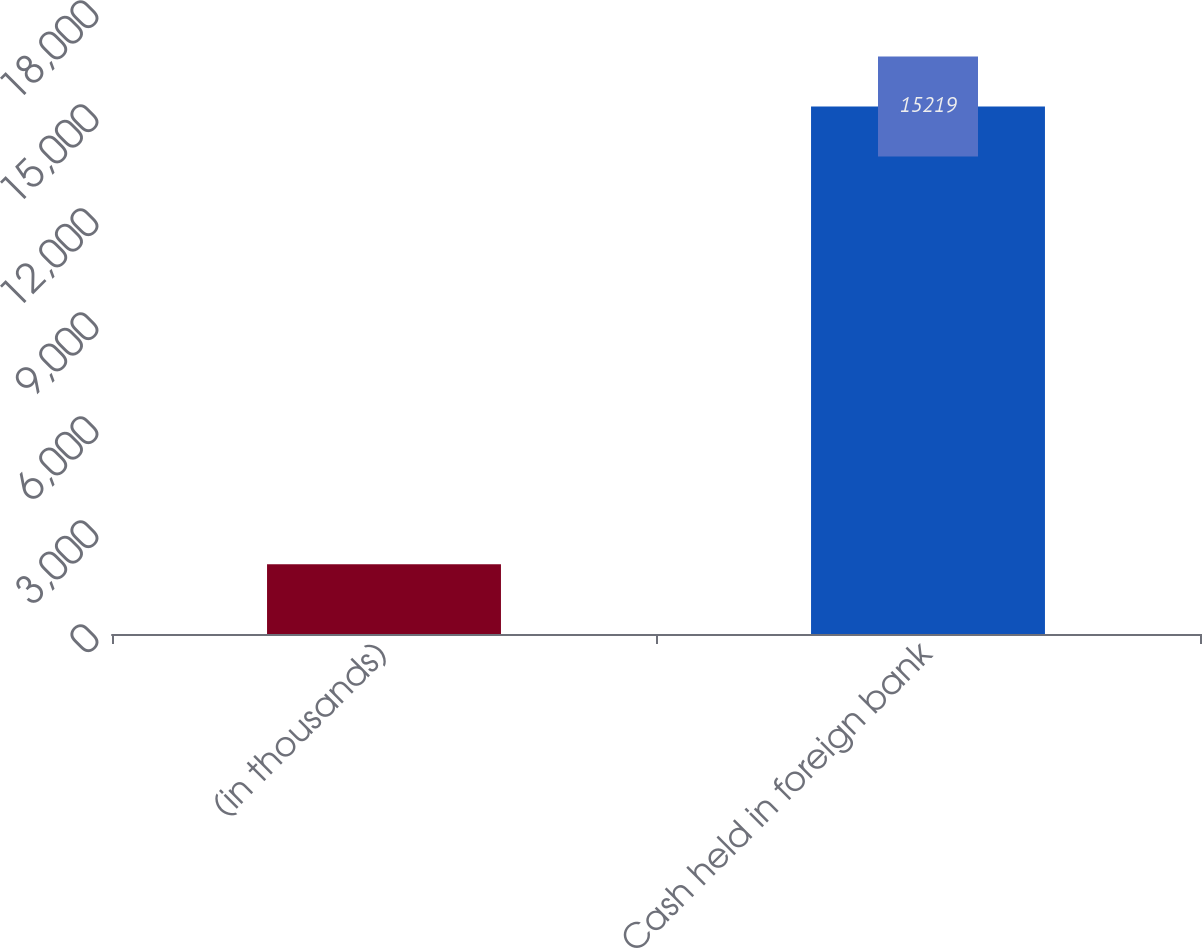Convert chart. <chart><loc_0><loc_0><loc_500><loc_500><bar_chart><fcel>(in thousands)<fcel>Cash held in foreign bank<nl><fcel>2010<fcel>15219<nl></chart> 